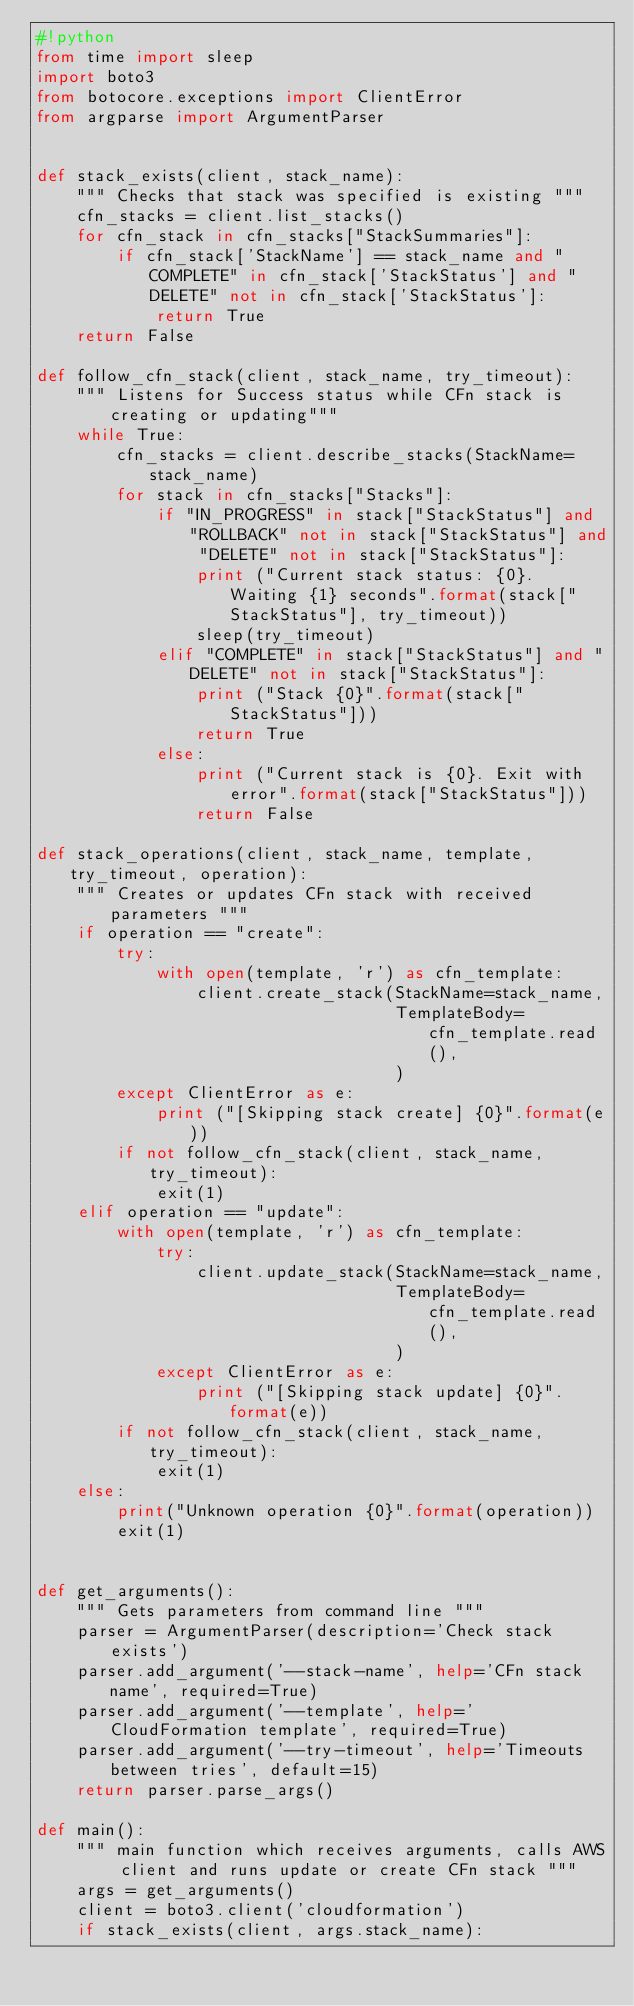<code> <loc_0><loc_0><loc_500><loc_500><_Python_>#!python
from time import sleep
import boto3
from botocore.exceptions import ClientError
from argparse import ArgumentParser


def stack_exists(client, stack_name):
    """ Checks that stack was specified is existing """
    cfn_stacks = client.list_stacks()
    for cfn_stack in cfn_stacks["StackSummaries"]:
        if cfn_stack['StackName'] == stack_name and "COMPLETE" in cfn_stack['StackStatus'] and "DELETE" not in cfn_stack['StackStatus']:
            return True
    return False

def follow_cfn_stack(client, stack_name, try_timeout):
    """ Listens for Success status while CFn stack is creating or updating"""
    while True:
        cfn_stacks = client.describe_stacks(StackName=stack_name)
        for stack in cfn_stacks["Stacks"]:
            if "IN_PROGRESS" in stack["StackStatus"] and "ROLLBACK" not in stack["StackStatus"] and "DELETE" not in stack["StackStatus"]:
                print ("Current stack status: {0}. Waiting {1} seconds".format(stack["StackStatus"], try_timeout))
                sleep(try_timeout)
            elif "COMPLETE" in stack["StackStatus"] and "DELETE" not in stack["StackStatus"]:
                print ("Stack {0}".format(stack["StackStatus"]))
                return True
            else:
                print ("Current stack is {0}. Exit with error".format(stack["StackStatus"]))
                return False

def stack_operations(client, stack_name, template, try_timeout, operation):
    """ Creates or updates CFn stack with received parameters """
    if operation == "create":
        try:
            with open(template, 'r') as cfn_template:
                client.create_stack(StackName=stack_name,
                                    TemplateBody=cfn_template.read(),
                                    )
        except ClientError as e:
            print ("[Skipping stack create] {0}".format(e))
        if not follow_cfn_stack(client, stack_name, try_timeout):
            exit(1)
    elif operation == "update":
        with open(template, 'r') as cfn_template:
            try:
                client.update_stack(StackName=stack_name,
                                    TemplateBody=cfn_template.read(),
                                    )
            except ClientError as e:
                print ("[Skipping stack update] {0}".format(e))
        if not follow_cfn_stack(client, stack_name, try_timeout):
            exit(1)
    else:
        print("Unknown operation {0}".format(operation))
        exit(1)


def get_arguments():
    """ Gets parameters from command line """
    parser = ArgumentParser(description='Check stack exists')
    parser.add_argument('--stack-name', help='CFn stack name', required=True)
    parser.add_argument('--template', help='CloudFormation template', required=True)
    parser.add_argument('--try-timeout', help='Timeouts between tries', default=15)
    return parser.parse_args()

def main():
    """ main function which receives arguments, calls AWS client and runs update or create CFn stack """
    args = get_arguments()
    client = boto3.client('cloudformation')
    if stack_exists(client, args.stack_name):</code> 